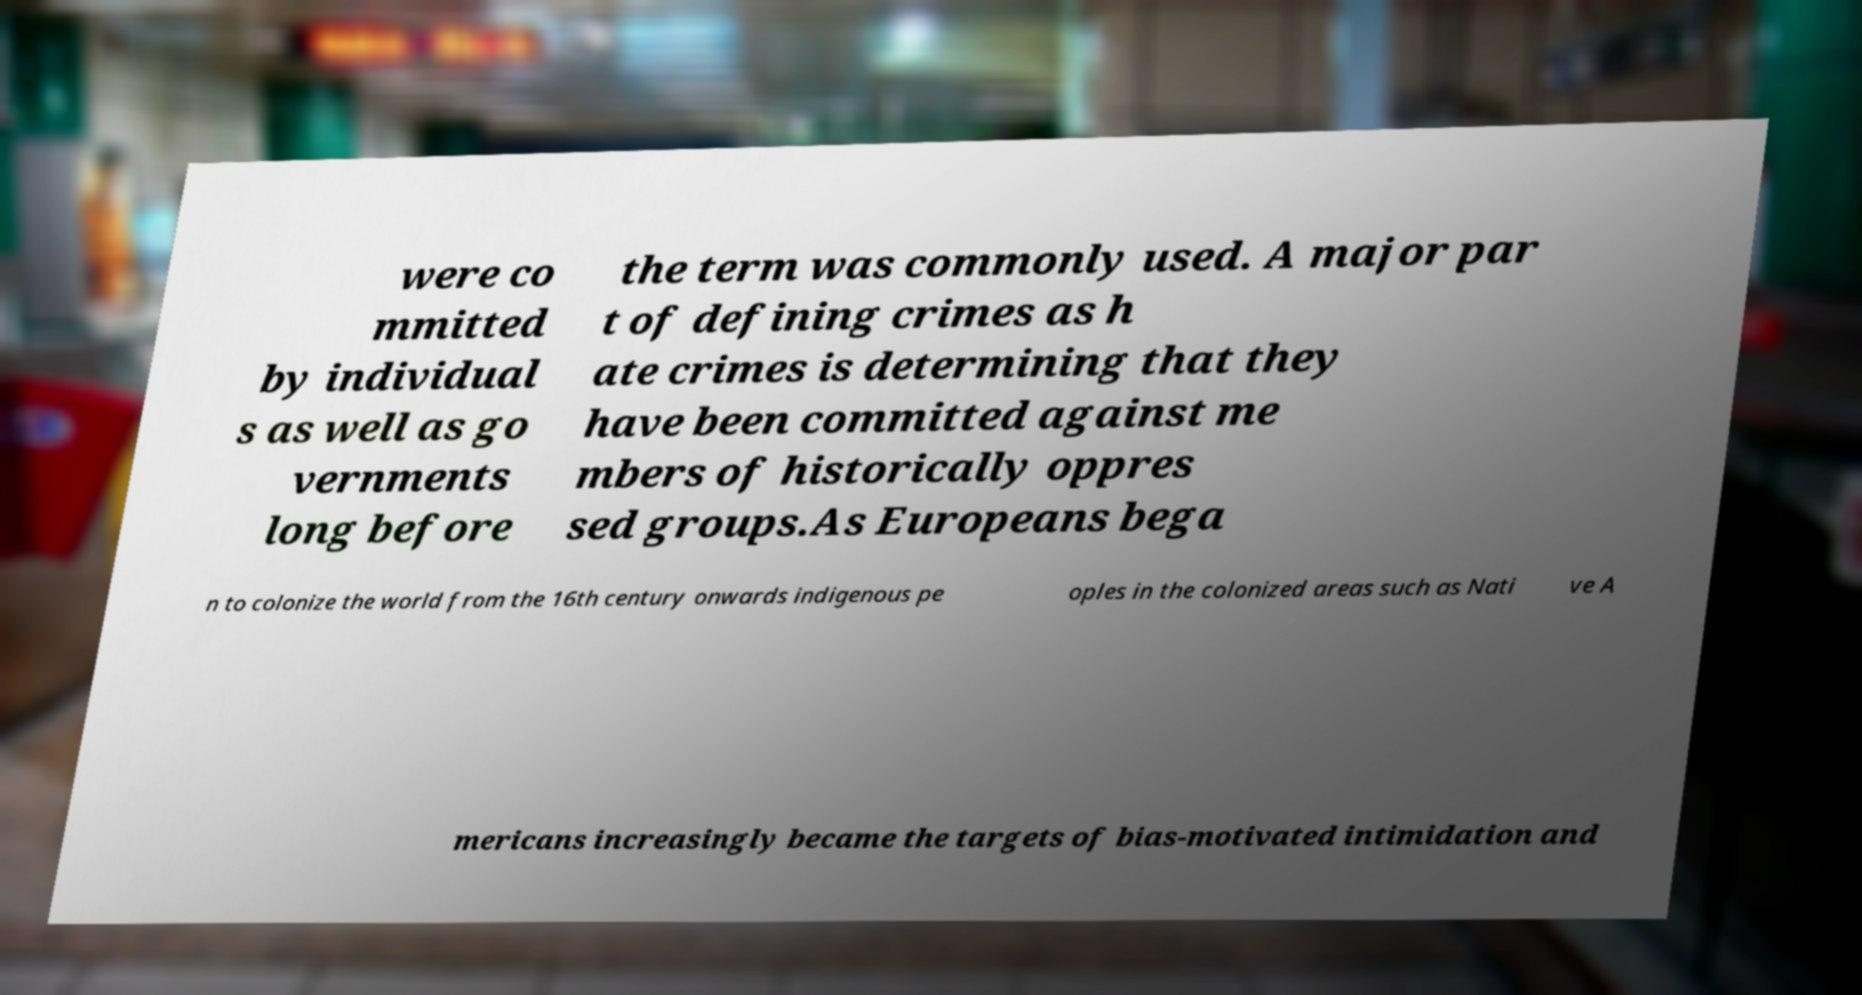Could you assist in decoding the text presented in this image and type it out clearly? were co mmitted by individual s as well as go vernments long before the term was commonly used. A major par t of defining crimes as h ate crimes is determining that they have been committed against me mbers of historically oppres sed groups.As Europeans bega n to colonize the world from the 16th century onwards indigenous pe oples in the colonized areas such as Nati ve A mericans increasingly became the targets of bias-motivated intimidation and 